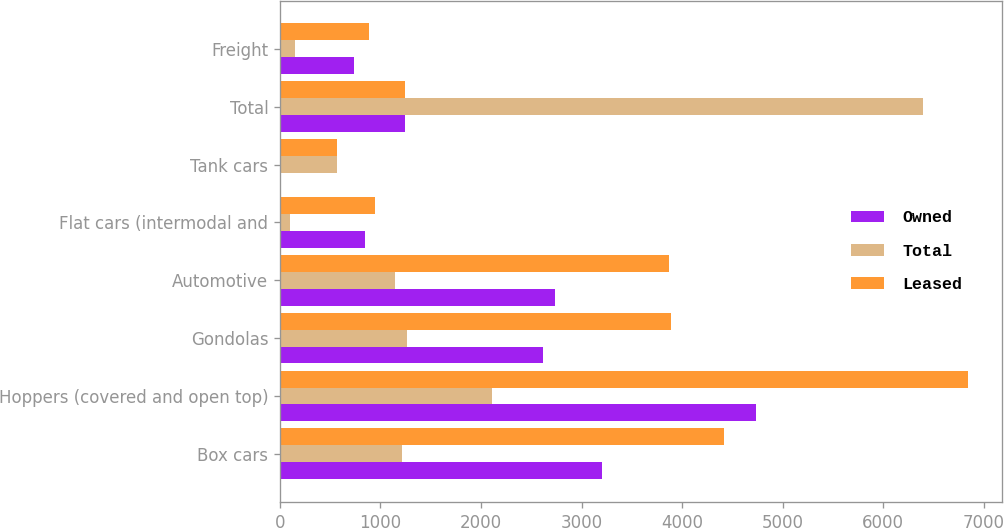Convert chart to OTSL. <chart><loc_0><loc_0><loc_500><loc_500><stacked_bar_chart><ecel><fcel>Box cars<fcel>Hoppers (covered and open top)<fcel>Gondolas<fcel>Automotive<fcel>Flat cars (intermodal and<fcel>Tank cars<fcel>Total<fcel>Freight<nl><fcel>Owned<fcel>3205<fcel>4735<fcel>2619<fcel>2731<fcel>850<fcel>4<fcel>1239.5<fcel>736<nl><fcel>Total<fcel>1212<fcel>2107<fcel>1267<fcel>1142<fcel>98<fcel>568<fcel>6394<fcel>146<nl><fcel>Leased<fcel>4417<fcel>6842<fcel>3886<fcel>3873<fcel>948<fcel>572<fcel>1239.5<fcel>882<nl></chart> 